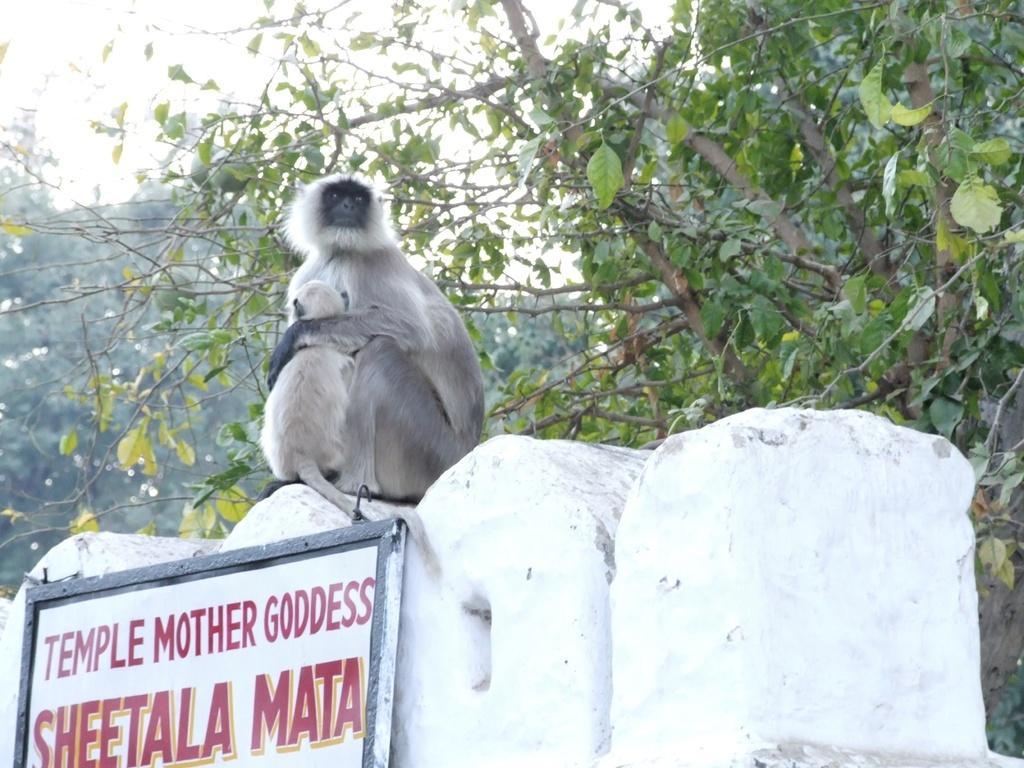In one or two sentences, can you explain what this image depicts? In the image there are two monkeys sitting on a temple wall, behind the monkey's there are many branches of a tree. 